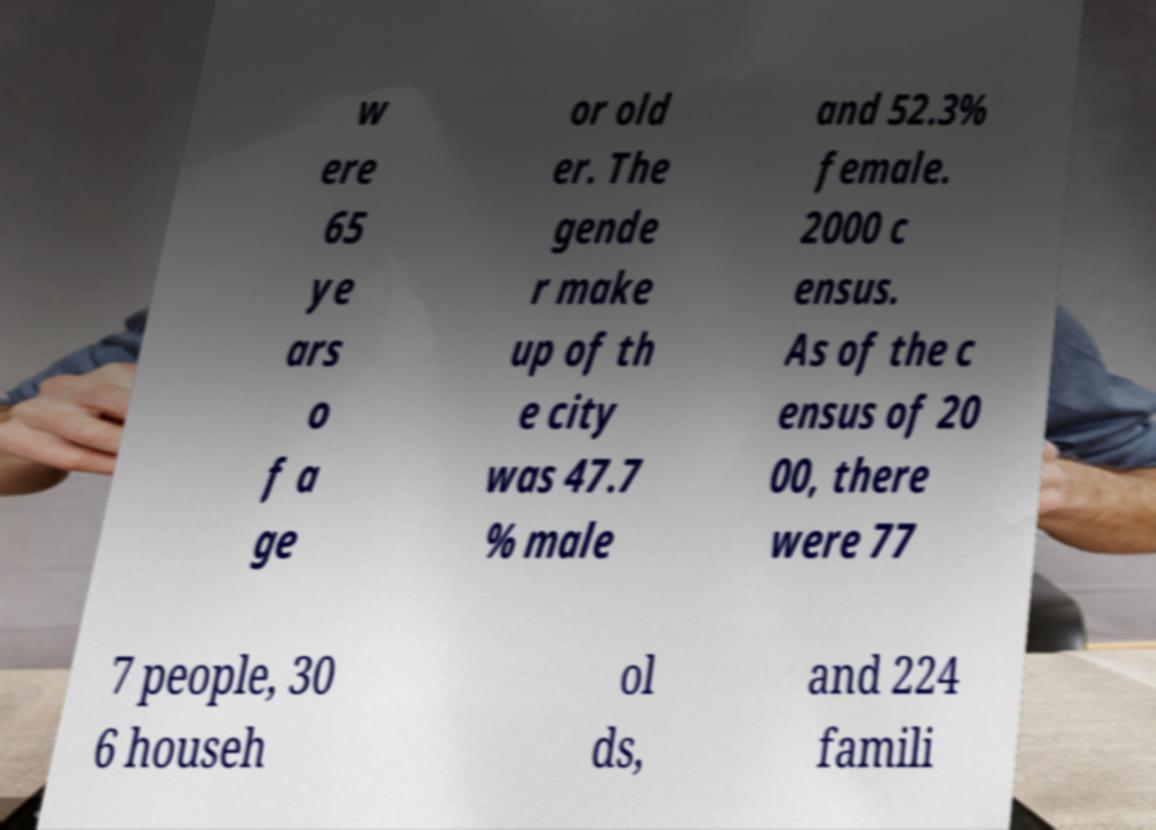What messages or text are displayed in this image? I need them in a readable, typed format. w ere 65 ye ars o f a ge or old er. The gende r make up of th e city was 47.7 % male and 52.3% female. 2000 c ensus. As of the c ensus of 20 00, there were 77 7 people, 30 6 househ ol ds, and 224 famili 